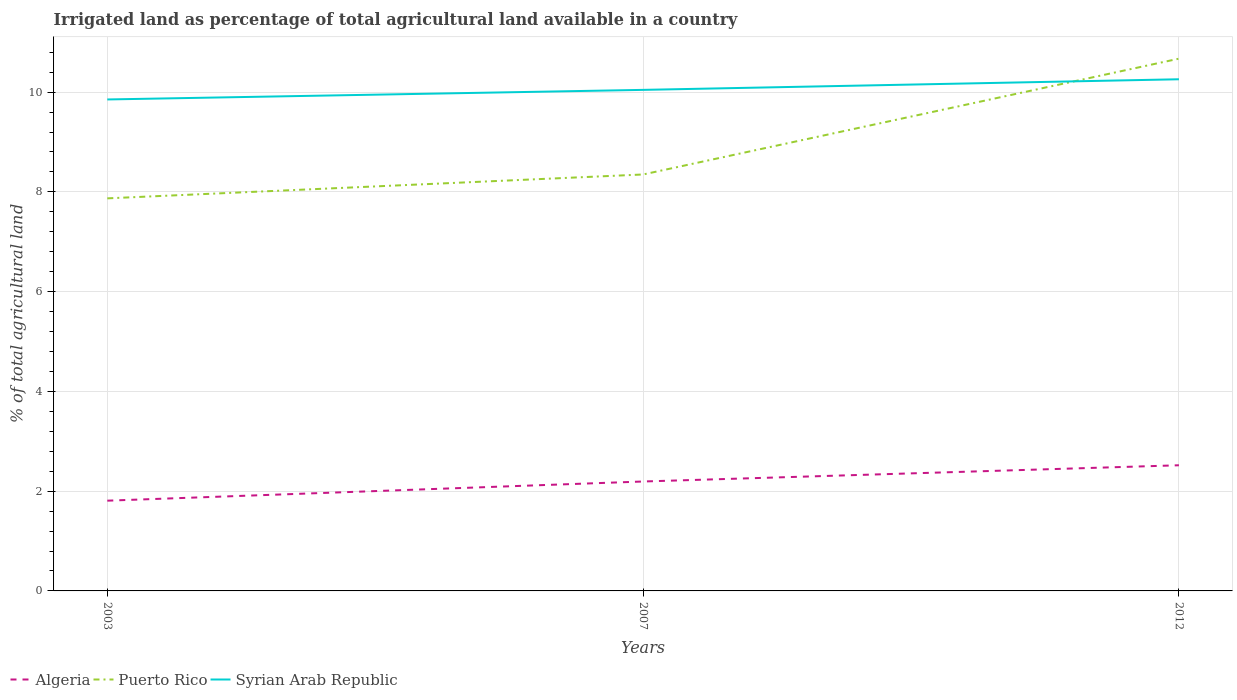Does the line corresponding to Puerto Rico intersect with the line corresponding to Algeria?
Ensure brevity in your answer.  No. Is the number of lines equal to the number of legend labels?
Provide a short and direct response. Yes. Across all years, what is the maximum percentage of irrigated land in Algeria?
Your answer should be compact. 1.81. What is the total percentage of irrigated land in Syrian Arab Republic in the graph?
Your response must be concise. -0.4. What is the difference between the highest and the second highest percentage of irrigated land in Algeria?
Ensure brevity in your answer.  0.71. How many lines are there?
Provide a succinct answer. 3. How many years are there in the graph?
Your answer should be compact. 3. Are the values on the major ticks of Y-axis written in scientific E-notation?
Give a very brief answer. No. Does the graph contain grids?
Provide a short and direct response. Yes. Where does the legend appear in the graph?
Your answer should be compact. Bottom left. How many legend labels are there?
Offer a very short reply. 3. How are the legend labels stacked?
Your answer should be very brief. Horizontal. What is the title of the graph?
Ensure brevity in your answer.  Irrigated land as percentage of total agricultural land available in a country. Does "St. Martin (French part)" appear as one of the legend labels in the graph?
Offer a terse response. No. What is the label or title of the Y-axis?
Provide a short and direct response. % of total agricultural land. What is the % of total agricultural land of Algeria in 2003?
Provide a short and direct response. 1.81. What is the % of total agricultural land in Puerto Rico in 2003?
Your response must be concise. 7.87. What is the % of total agricultural land in Syrian Arab Republic in 2003?
Your answer should be compact. 9.85. What is the % of total agricultural land in Algeria in 2007?
Make the answer very short. 2.19. What is the % of total agricultural land in Puerto Rico in 2007?
Your answer should be compact. 8.35. What is the % of total agricultural land of Syrian Arab Republic in 2007?
Offer a very short reply. 10.05. What is the % of total agricultural land of Algeria in 2012?
Keep it short and to the point. 2.52. What is the % of total agricultural land in Puerto Rico in 2012?
Keep it short and to the point. 10.67. What is the % of total agricultural land of Syrian Arab Republic in 2012?
Keep it short and to the point. 10.26. Across all years, what is the maximum % of total agricultural land of Algeria?
Give a very brief answer. 2.52. Across all years, what is the maximum % of total agricultural land in Puerto Rico?
Keep it short and to the point. 10.67. Across all years, what is the maximum % of total agricultural land of Syrian Arab Republic?
Make the answer very short. 10.26. Across all years, what is the minimum % of total agricultural land of Algeria?
Keep it short and to the point. 1.81. Across all years, what is the minimum % of total agricultural land of Puerto Rico?
Offer a very short reply. 7.87. Across all years, what is the minimum % of total agricultural land of Syrian Arab Republic?
Give a very brief answer. 9.85. What is the total % of total agricultural land of Algeria in the graph?
Provide a succinct answer. 6.52. What is the total % of total agricultural land in Puerto Rico in the graph?
Provide a short and direct response. 26.89. What is the total % of total agricultural land of Syrian Arab Republic in the graph?
Give a very brief answer. 30.16. What is the difference between the % of total agricultural land in Algeria in 2003 and that in 2007?
Your response must be concise. -0.38. What is the difference between the % of total agricultural land of Puerto Rico in 2003 and that in 2007?
Make the answer very short. -0.48. What is the difference between the % of total agricultural land in Syrian Arab Republic in 2003 and that in 2007?
Provide a succinct answer. -0.19. What is the difference between the % of total agricultural land of Algeria in 2003 and that in 2012?
Provide a short and direct response. -0.71. What is the difference between the % of total agricultural land in Puerto Rico in 2003 and that in 2012?
Give a very brief answer. -2.8. What is the difference between the % of total agricultural land in Syrian Arab Republic in 2003 and that in 2012?
Your answer should be very brief. -0.4. What is the difference between the % of total agricultural land of Algeria in 2007 and that in 2012?
Your answer should be compact. -0.33. What is the difference between the % of total agricultural land of Puerto Rico in 2007 and that in 2012?
Provide a succinct answer. -2.32. What is the difference between the % of total agricultural land in Syrian Arab Republic in 2007 and that in 2012?
Provide a succinct answer. -0.21. What is the difference between the % of total agricultural land in Algeria in 2003 and the % of total agricultural land in Puerto Rico in 2007?
Your answer should be very brief. -6.54. What is the difference between the % of total agricultural land in Algeria in 2003 and the % of total agricultural land in Syrian Arab Republic in 2007?
Provide a succinct answer. -8.24. What is the difference between the % of total agricultural land of Puerto Rico in 2003 and the % of total agricultural land of Syrian Arab Republic in 2007?
Offer a very short reply. -2.17. What is the difference between the % of total agricultural land in Algeria in 2003 and the % of total agricultural land in Puerto Rico in 2012?
Make the answer very short. -8.86. What is the difference between the % of total agricultural land of Algeria in 2003 and the % of total agricultural land of Syrian Arab Republic in 2012?
Keep it short and to the point. -8.45. What is the difference between the % of total agricultural land of Puerto Rico in 2003 and the % of total agricultural land of Syrian Arab Republic in 2012?
Give a very brief answer. -2.39. What is the difference between the % of total agricultural land of Algeria in 2007 and the % of total agricultural land of Puerto Rico in 2012?
Offer a very short reply. -8.48. What is the difference between the % of total agricultural land of Algeria in 2007 and the % of total agricultural land of Syrian Arab Republic in 2012?
Provide a short and direct response. -8.06. What is the difference between the % of total agricultural land of Puerto Rico in 2007 and the % of total agricultural land of Syrian Arab Republic in 2012?
Offer a very short reply. -1.91. What is the average % of total agricultural land of Algeria per year?
Make the answer very short. 2.17. What is the average % of total agricultural land of Puerto Rico per year?
Make the answer very short. 8.96. What is the average % of total agricultural land in Syrian Arab Republic per year?
Keep it short and to the point. 10.05. In the year 2003, what is the difference between the % of total agricultural land in Algeria and % of total agricultural land in Puerto Rico?
Your answer should be very brief. -6.06. In the year 2003, what is the difference between the % of total agricultural land in Algeria and % of total agricultural land in Syrian Arab Republic?
Ensure brevity in your answer.  -8.04. In the year 2003, what is the difference between the % of total agricultural land of Puerto Rico and % of total agricultural land of Syrian Arab Republic?
Offer a very short reply. -1.98. In the year 2007, what is the difference between the % of total agricultural land of Algeria and % of total agricultural land of Puerto Rico?
Your response must be concise. -6.16. In the year 2007, what is the difference between the % of total agricultural land of Algeria and % of total agricultural land of Syrian Arab Republic?
Offer a terse response. -7.85. In the year 2007, what is the difference between the % of total agricultural land of Puerto Rico and % of total agricultural land of Syrian Arab Republic?
Your answer should be very brief. -1.7. In the year 2012, what is the difference between the % of total agricultural land in Algeria and % of total agricultural land in Puerto Rico?
Your answer should be compact. -8.15. In the year 2012, what is the difference between the % of total agricultural land in Algeria and % of total agricultural land in Syrian Arab Republic?
Keep it short and to the point. -7.74. In the year 2012, what is the difference between the % of total agricultural land in Puerto Rico and % of total agricultural land in Syrian Arab Republic?
Your response must be concise. 0.41. What is the ratio of the % of total agricultural land of Algeria in 2003 to that in 2007?
Make the answer very short. 0.82. What is the ratio of the % of total agricultural land in Puerto Rico in 2003 to that in 2007?
Make the answer very short. 0.94. What is the ratio of the % of total agricultural land in Syrian Arab Republic in 2003 to that in 2007?
Offer a very short reply. 0.98. What is the ratio of the % of total agricultural land of Algeria in 2003 to that in 2012?
Your answer should be very brief. 0.72. What is the ratio of the % of total agricultural land of Puerto Rico in 2003 to that in 2012?
Give a very brief answer. 0.74. What is the ratio of the % of total agricultural land in Syrian Arab Republic in 2003 to that in 2012?
Provide a succinct answer. 0.96. What is the ratio of the % of total agricultural land of Algeria in 2007 to that in 2012?
Offer a very short reply. 0.87. What is the ratio of the % of total agricultural land of Puerto Rico in 2007 to that in 2012?
Offer a very short reply. 0.78. What is the ratio of the % of total agricultural land in Syrian Arab Republic in 2007 to that in 2012?
Offer a very short reply. 0.98. What is the difference between the highest and the second highest % of total agricultural land of Algeria?
Your answer should be very brief. 0.33. What is the difference between the highest and the second highest % of total agricultural land in Puerto Rico?
Your answer should be compact. 2.32. What is the difference between the highest and the second highest % of total agricultural land in Syrian Arab Republic?
Give a very brief answer. 0.21. What is the difference between the highest and the lowest % of total agricultural land of Algeria?
Provide a succinct answer. 0.71. What is the difference between the highest and the lowest % of total agricultural land in Puerto Rico?
Your response must be concise. 2.8. What is the difference between the highest and the lowest % of total agricultural land of Syrian Arab Republic?
Offer a very short reply. 0.4. 